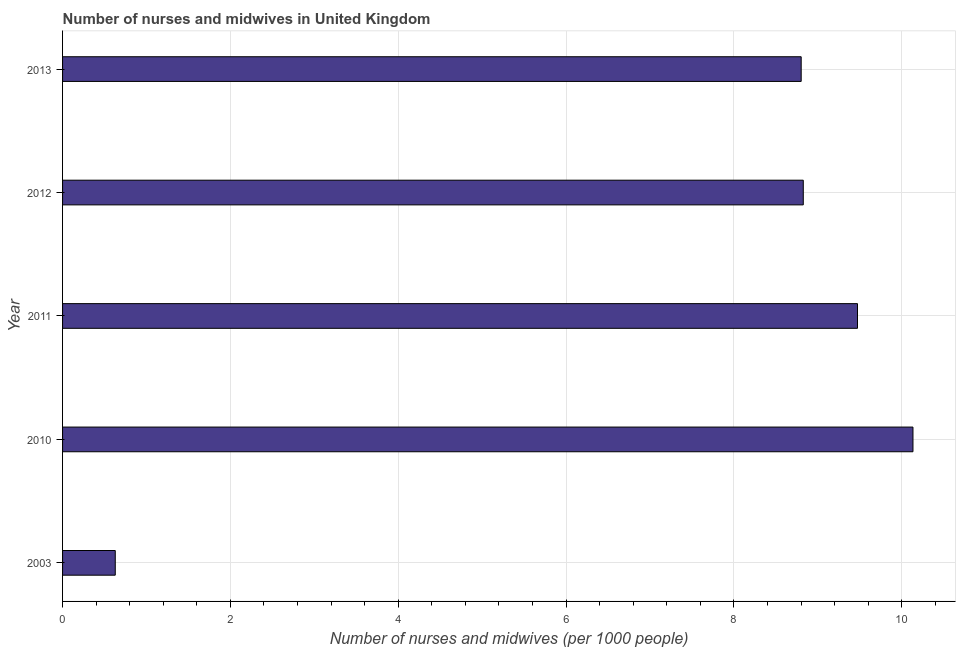Does the graph contain any zero values?
Ensure brevity in your answer.  No. Does the graph contain grids?
Ensure brevity in your answer.  Yes. What is the title of the graph?
Give a very brief answer. Number of nurses and midwives in United Kingdom. What is the label or title of the X-axis?
Make the answer very short. Number of nurses and midwives (per 1000 people). What is the label or title of the Y-axis?
Provide a succinct answer. Year. What is the number of nurses and midwives in 2013?
Provide a short and direct response. 8.8. Across all years, what is the maximum number of nurses and midwives?
Offer a very short reply. 10.13. Across all years, what is the minimum number of nurses and midwives?
Provide a short and direct response. 0.63. In which year was the number of nurses and midwives maximum?
Offer a very short reply. 2010. What is the sum of the number of nurses and midwives?
Give a very brief answer. 37.86. What is the difference between the number of nurses and midwives in 2010 and 2012?
Ensure brevity in your answer.  1.31. What is the average number of nurses and midwives per year?
Your answer should be very brief. 7.57. What is the median number of nurses and midwives?
Ensure brevity in your answer.  8.83. What is the ratio of the number of nurses and midwives in 2011 to that in 2013?
Provide a succinct answer. 1.08. Is the number of nurses and midwives in 2010 less than that in 2013?
Ensure brevity in your answer.  No. What is the difference between the highest and the second highest number of nurses and midwives?
Provide a succinct answer. 0.66. What is the difference between the highest and the lowest number of nurses and midwives?
Provide a short and direct response. 9.5. What is the difference between two consecutive major ticks on the X-axis?
Provide a succinct answer. 2. What is the Number of nurses and midwives (per 1000 people) in 2003?
Offer a terse response. 0.63. What is the Number of nurses and midwives (per 1000 people) of 2010?
Make the answer very short. 10.13. What is the Number of nurses and midwives (per 1000 people) of 2011?
Your answer should be very brief. 9.47. What is the Number of nurses and midwives (per 1000 people) in 2012?
Your answer should be compact. 8.83. What is the Number of nurses and midwives (per 1000 people) of 2013?
Offer a very short reply. 8.8. What is the difference between the Number of nurses and midwives (per 1000 people) in 2003 and 2010?
Provide a succinct answer. -9.51. What is the difference between the Number of nurses and midwives (per 1000 people) in 2003 and 2011?
Offer a very short reply. -8.84. What is the difference between the Number of nurses and midwives (per 1000 people) in 2003 and 2012?
Provide a short and direct response. -8.2. What is the difference between the Number of nurses and midwives (per 1000 people) in 2003 and 2013?
Keep it short and to the point. -8.17. What is the difference between the Number of nurses and midwives (per 1000 people) in 2010 and 2011?
Provide a short and direct response. 0.66. What is the difference between the Number of nurses and midwives (per 1000 people) in 2010 and 2012?
Make the answer very short. 1.31. What is the difference between the Number of nurses and midwives (per 1000 people) in 2010 and 2013?
Your answer should be compact. 1.33. What is the difference between the Number of nurses and midwives (per 1000 people) in 2011 and 2012?
Provide a short and direct response. 0.65. What is the difference between the Number of nurses and midwives (per 1000 people) in 2011 and 2013?
Give a very brief answer. 0.67. What is the difference between the Number of nurses and midwives (per 1000 people) in 2012 and 2013?
Offer a terse response. 0.03. What is the ratio of the Number of nurses and midwives (per 1000 people) in 2003 to that in 2010?
Give a very brief answer. 0.06. What is the ratio of the Number of nurses and midwives (per 1000 people) in 2003 to that in 2011?
Your response must be concise. 0.07. What is the ratio of the Number of nurses and midwives (per 1000 people) in 2003 to that in 2012?
Your response must be concise. 0.07. What is the ratio of the Number of nurses and midwives (per 1000 people) in 2003 to that in 2013?
Your answer should be very brief. 0.07. What is the ratio of the Number of nurses and midwives (per 1000 people) in 2010 to that in 2011?
Offer a terse response. 1.07. What is the ratio of the Number of nurses and midwives (per 1000 people) in 2010 to that in 2012?
Provide a short and direct response. 1.15. What is the ratio of the Number of nurses and midwives (per 1000 people) in 2010 to that in 2013?
Your answer should be very brief. 1.15. What is the ratio of the Number of nurses and midwives (per 1000 people) in 2011 to that in 2012?
Keep it short and to the point. 1.07. What is the ratio of the Number of nurses and midwives (per 1000 people) in 2011 to that in 2013?
Offer a terse response. 1.08. What is the ratio of the Number of nurses and midwives (per 1000 people) in 2012 to that in 2013?
Your response must be concise. 1. 